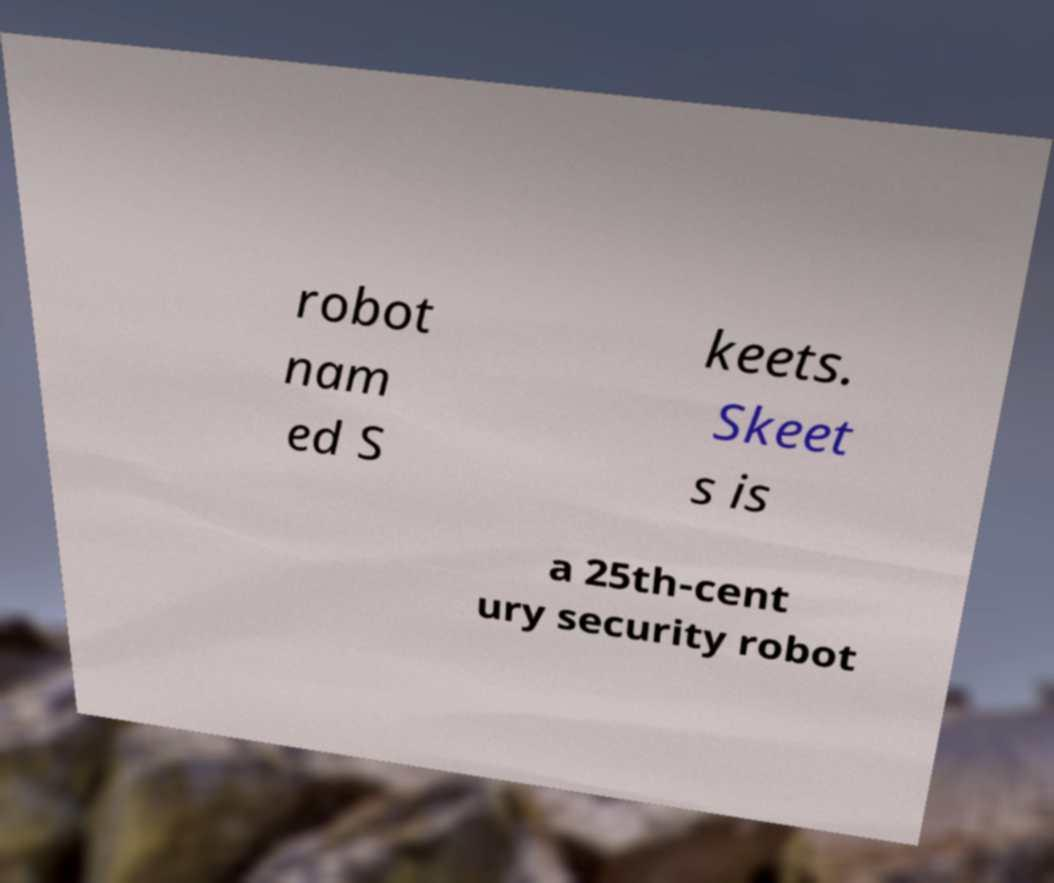I need the written content from this picture converted into text. Can you do that? robot nam ed S keets. Skeet s is a 25th-cent ury security robot 